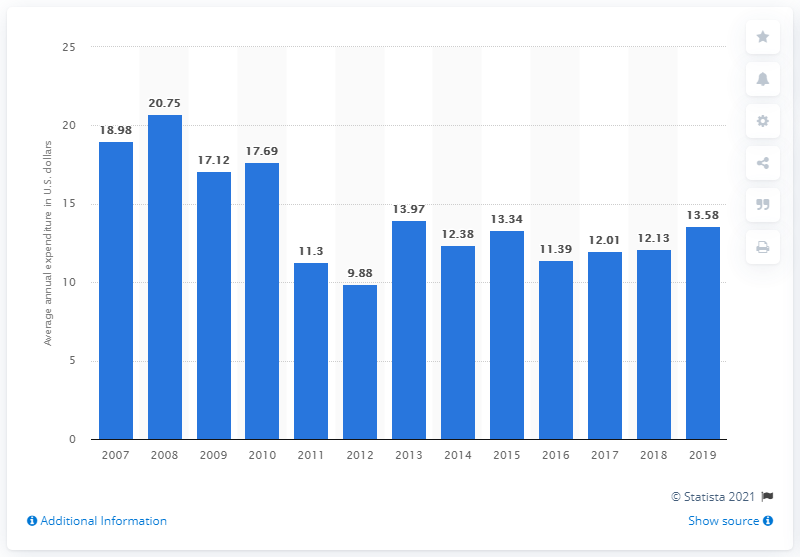Mention a couple of crucial points in this snapshot. In 2019, the average expenditure on curtains and draperies per consumer unit in the United States was $13.58. 